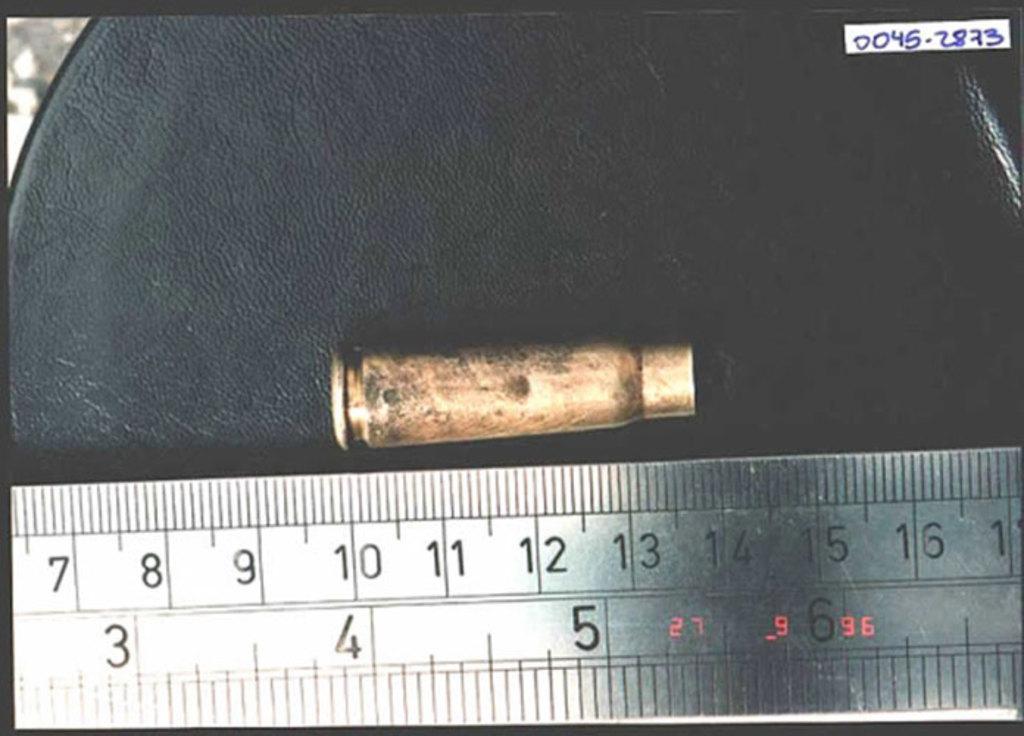What's the large number on the bottom left?
Your answer should be very brief. 3. What year was this image taken?
Your answer should be very brief. 96. 